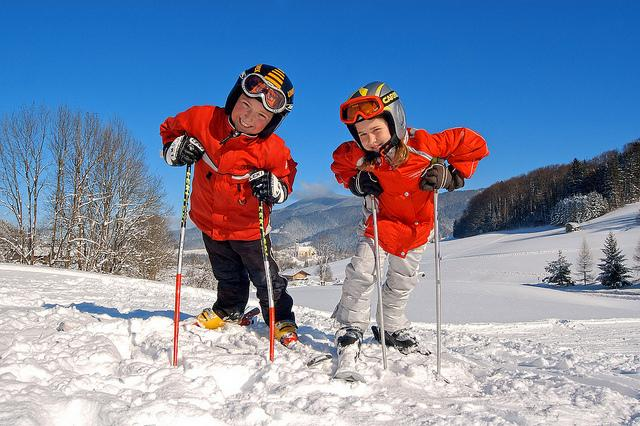Where is most of the kids weight?

Choices:
A) on heads
B) on feet
C) on arms
D) on skis on skis 